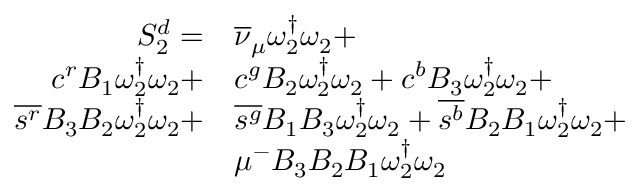<formula> <loc_0><loc_0><loc_500><loc_500>\begin{array} { r l } { S _ { 2 } ^ { d } = } & { { \overline { \nu } _ { \mu } } \omega _ { 2 } ^ { \dagger } \omega _ { 2 } + } \\ { { c } ^ { r } { B _ { 1 } } \omega _ { 2 } ^ { \dagger } \omega _ { 2 } + } & { { c } ^ { g } { B _ { 2 } } \omega _ { 2 } ^ { \dagger } \omega _ { 2 } + { c } ^ { b } { B _ { 3 } } \omega _ { 2 } ^ { \dagger } \omega _ { 2 } + } \\ { \overline { { s ^ { r } } } { B _ { 3 } } { B _ { 2 } } \omega _ { 2 } ^ { \dagger } \omega _ { 2 } + } & { \overline { { s ^ { g } } } { B _ { 1 } } { B _ { 3 } } \omega _ { 2 } ^ { \dagger } \omega _ { 2 } + \overline { { s ^ { b } } } { B _ { 2 } } { B _ { 1 } } \omega _ { 2 } ^ { \dagger } \omega _ { 2 } + } \\ & { \mu ^ { - } { B _ { 3 } } { B _ { 2 } } { B _ { 1 } } \omega _ { 2 } ^ { \dagger } \omega _ { 2 } } \end{array}</formula> 